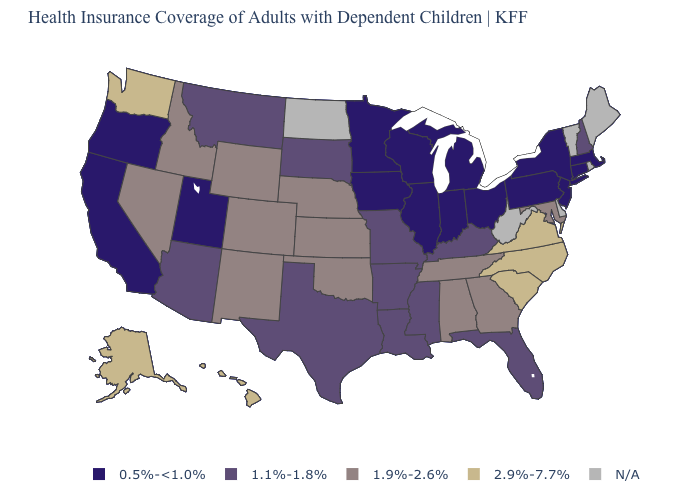What is the value of Arkansas?
Write a very short answer. 1.1%-1.8%. What is the value of South Carolina?
Write a very short answer. 2.9%-7.7%. What is the lowest value in the USA?
Quick response, please. 0.5%-<1.0%. What is the lowest value in the USA?
Concise answer only. 0.5%-<1.0%. What is the lowest value in the West?
Write a very short answer. 0.5%-<1.0%. Among the states that border Montana , which have the lowest value?
Answer briefly. South Dakota. Name the states that have a value in the range 1.9%-2.6%?
Concise answer only. Alabama, Colorado, Georgia, Idaho, Kansas, Maryland, Nebraska, Nevada, New Mexico, Oklahoma, Tennessee, Wyoming. Which states have the highest value in the USA?
Quick response, please. Alaska, Hawaii, North Carolina, South Carolina, Virginia, Washington. What is the highest value in states that border New Mexico?
Keep it brief. 1.9%-2.6%. What is the value of South Dakota?
Short answer required. 1.1%-1.8%. Among the states that border Washington , does Idaho have the highest value?
Short answer required. Yes. Name the states that have a value in the range 2.9%-7.7%?
Be succinct. Alaska, Hawaii, North Carolina, South Carolina, Virginia, Washington. 